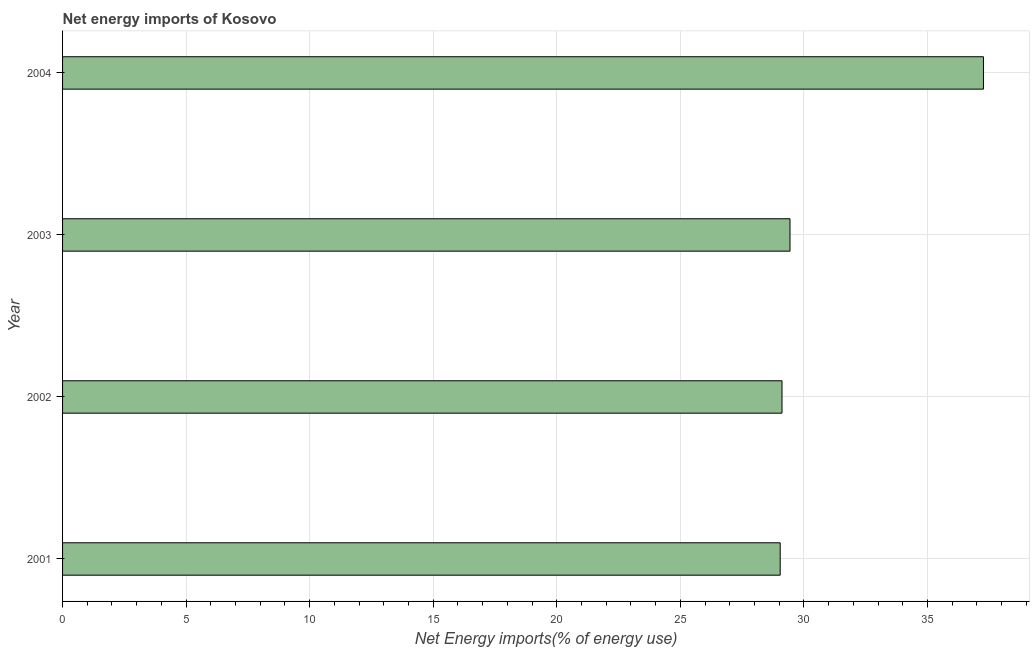Does the graph contain any zero values?
Give a very brief answer. No. What is the title of the graph?
Give a very brief answer. Net energy imports of Kosovo. What is the label or title of the X-axis?
Your answer should be compact. Net Energy imports(% of energy use). What is the label or title of the Y-axis?
Your answer should be compact. Year. What is the energy imports in 2004?
Offer a very short reply. 37.27. Across all years, what is the maximum energy imports?
Offer a very short reply. 37.27. Across all years, what is the minimum energy imports?
Make the answer very short. 29.04. In which year was the energy imports maximum?
Provide a succinct answer. 2004. In which year was the energy imports minimum?
Provide a short and direct response. 2001. What is the sum of the energy imports?
Provide a succinct answer. 124.86. What is the difference between the energy imports in 2001 and 2004?
Ensure brevity in your answer.  -8.23. What is the average energy imports per year?
Provide a succinct answer. 31.21. What is the median energy imports?
Make the answer very short. 29.28. Do a majority of the years between 2001 and 2004 (inclusive) have energy imports greater than 16 %?
Provide a succinct answer. Yes. What is the ratio of the energy imports in 2002 to that in 2003?
Offer a terse response. 0.99. Is the energy imports in 2001 less than that in 2004?
Your answer should be compact. Yes. Is the difference between the energy imports in 2001 and 2003 greater than the difference between any two years?
Provide a succinct answer. No. What is the difference between the highest and the second highest energy imports?
Give a very brief answer. 7.83. What is the difference between the highest and the lowest energy imports?
Offer a very short reply. 8.23. In how many years, is the energy imports greater than the average energy imports taken over all years?
Make the answer very short. 1. How many bars are there?
Keep it short and to the point. 4. Are all the bars in the graph horizontal?
Offer a terse response. Yes. What is the difference between two consecutive major ticks on the X-axis?
Make the answer very short. 5. What is the Net Energy imports(% of energy use) in 2001?
Offer a terse response. 29.04. What is the Net Energy imports(% of energy use) in 2002?
Offer a terse response. 29.11. What is the Net Energy imports(% of energy use) of 2003?
Give a very brief answer. 29.44. What is the Net Energy imports(% of energy use) in 2004?
Your answer should be compact. 37.27. What is the difference between the Net Energy imports(% of energy use) in 2001 and 2002?
Offer a very short reply. -0.07. What is the difference between the Net Energy imports(% of energy use) in 2001 and 2003?
Your answer should be very brief. -0.4. What is the difference between the Net Energy imports(% of energy use) in 2001 and 2004?
Your response must be concise. -8.23. What is the difference between the Net Energy imports(% of energy use) in 2002 and 2003?
Keep it short and to the point. -0.32. What is the difference between the Net Energy imports(% of energy use) in 2002 and 2004?
Keep it short and to the point. -8.15. What is the difference between the Net Energy imports(% of energy use) in 2003 and 2004?
Your answer should be very brief. -7.83. What is the ratio of the Net Energy imports(% of energy use) in 2001 to that in 2002?
Provide a short and direct response. 1. What is the ratio of the Net Energy imports(% of energy use) in 2001 to that in 2003?
Keep it short and to the point. 0.99. What is the ratio of the Net Energy imports(% of energy use) in 2001 to that in 2004?
Make the answer very short. 0.78. What is the ratio of the Net Energy imports(% of energy use) in 2002 to that in 2003?
Your answer should be very brief. 0.99. What is the ratio of the Net Energy imports(% of energy use) in 2002 to that in 2004?
Offer a very short reply. 0.78. What is the ratio of the Net Energy imports(% of energy use) in 2003 to that in 2004?
Ensure brevity in your answer.  0.79. 